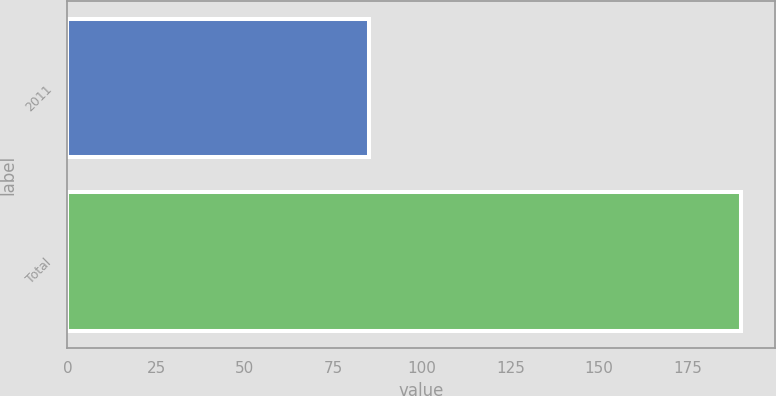Convert chart. <chart><loc_0><loc_0><loc_500><loc_500><bar_chart><fcel>2011<fcel>Total<nl><fcel>85<fcel>190<nl></chart> 